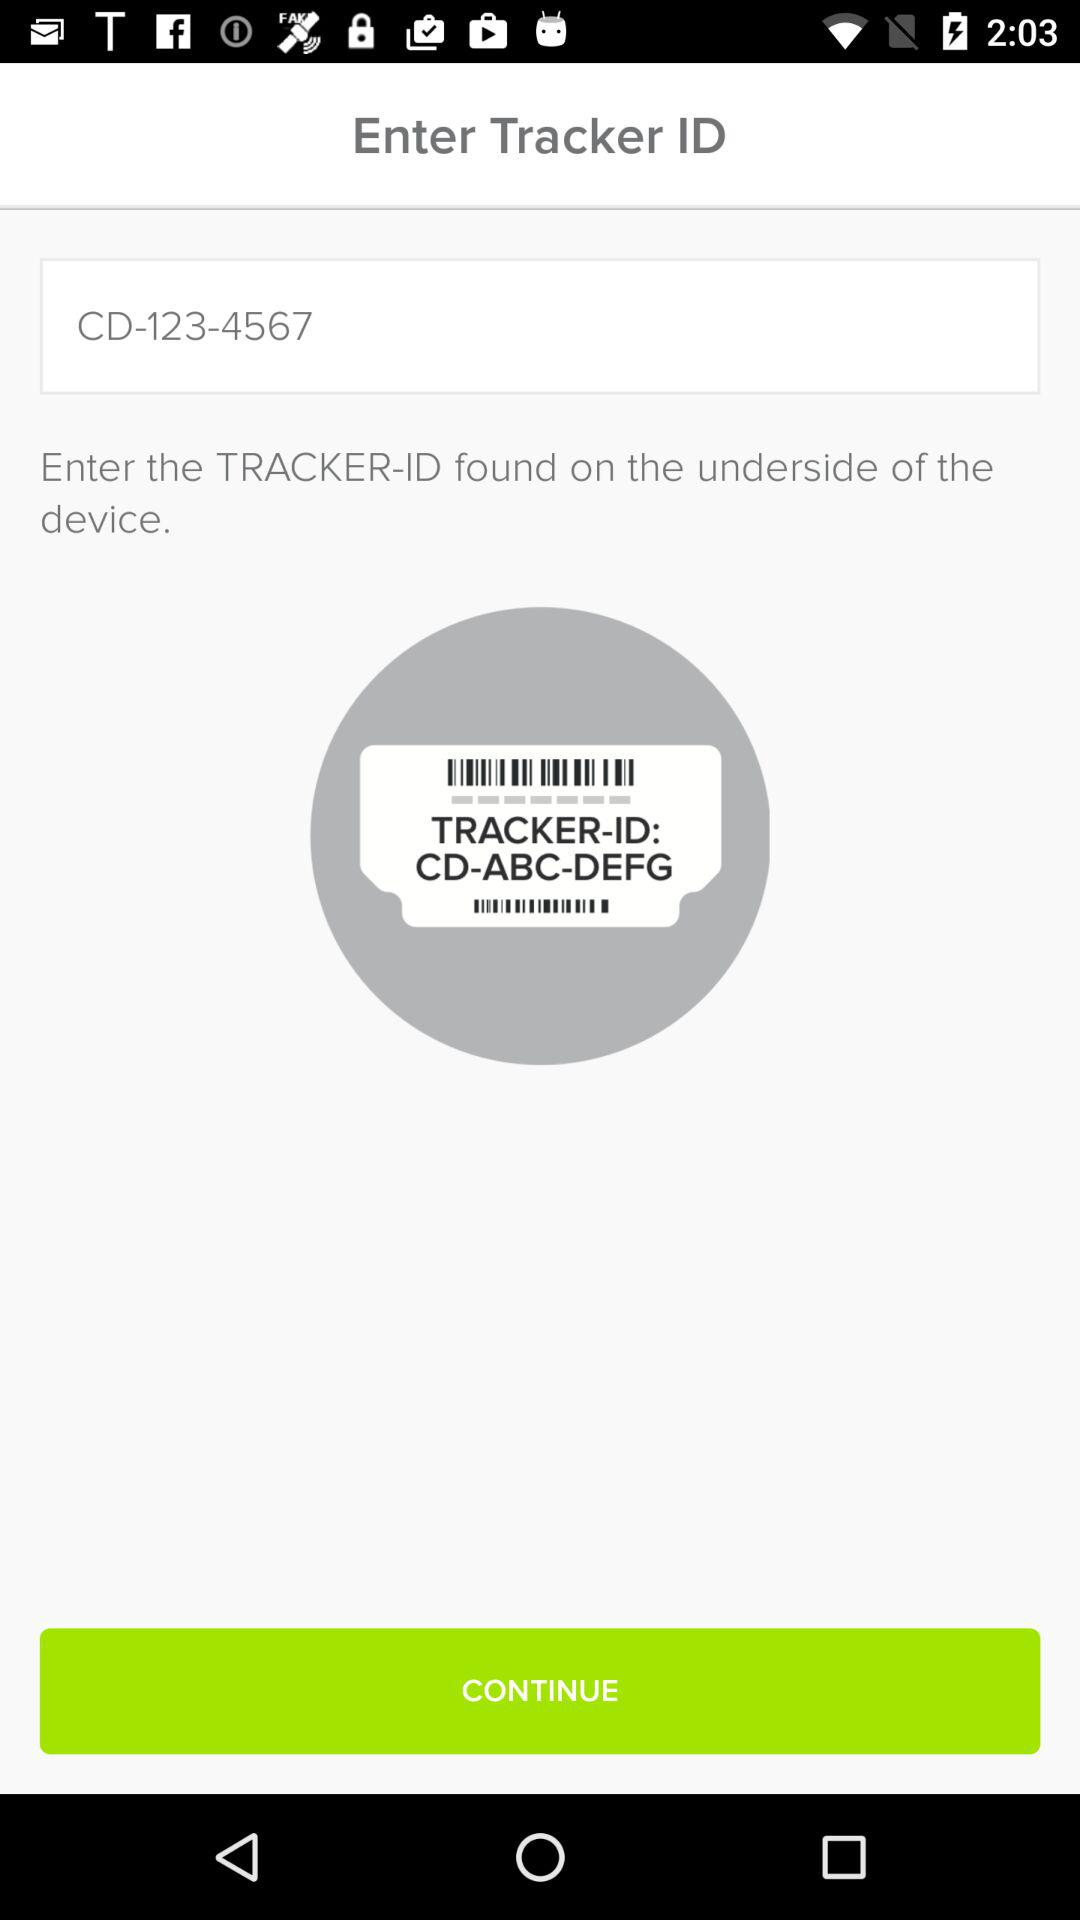What is the Tracker ID? The Tracker ID is CD-123-4567. 